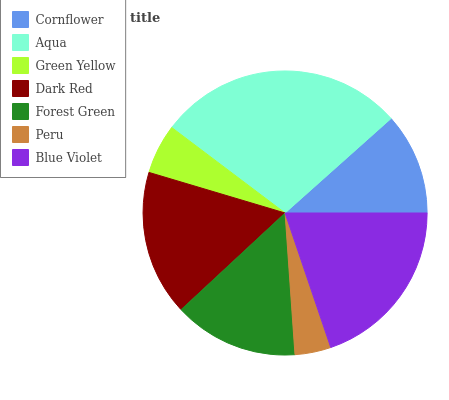Is Peru the minimum?
Answer yes or no. Yes. Is Aqua the maximum?
Answer yes or no. Yes. Is Green Yellow the minimum?
Answer yes or no. No. Is Green Yellow the maximum?
Answer yes or no. No. Is Aqua greater than Green Yellow?
Answer yes or no. Yes. Is Green Yellow less than Aqua?
Answer yes or no. Yes. Is Green Yellow greater than Aqua?
Answer yes or no. No. Is Aqua less than Green Yellow?
Answer yes or no. No. Is Forest Green the high median?
Answer yes or no. Yes. Is Forest Green the low median?
Answer yes or no. Yes. Is Cornflower the high median?
Answer yes or no. No. Is Peru the low median?
Answer yes or no. No. 